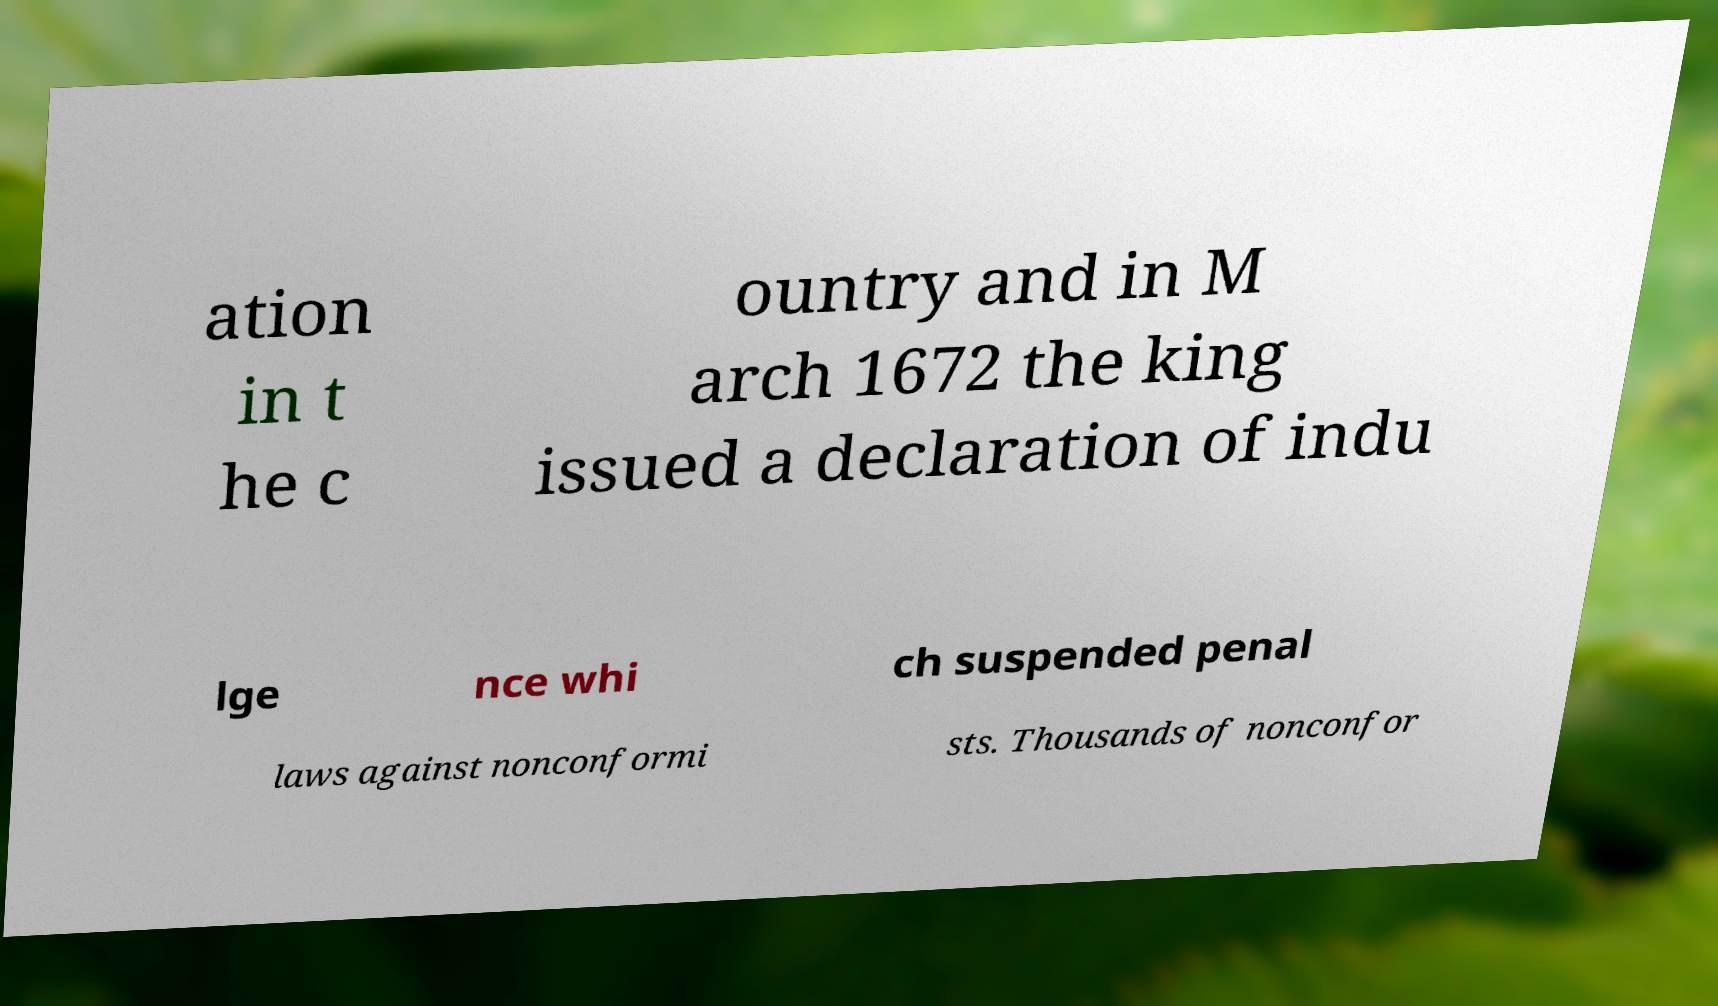Could you assist in decoding the text presented in this image and type it out clearly? ation in t he c ountry and in M arch 1672 the king issued a declaration of indu lge nce whi ch suspended penal laws against nonconformi sts. Thousands of nonconfor 